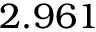<formula> <loc_0><loc_0><loc_500><loc_500>2 . 9 6 1</formula> 